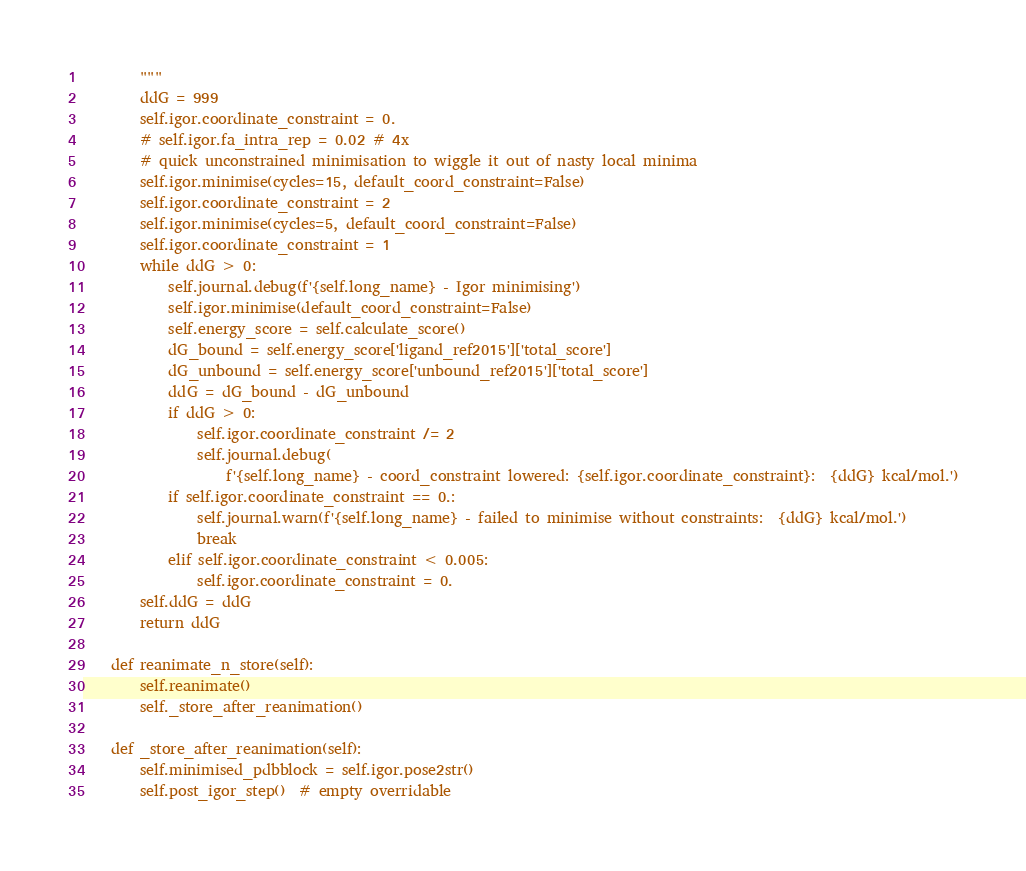<code> <loc_0><loc_0><loc_500><loc_500><_Python_>        """
        ddG = 999
        self.igor.coordinate_constraint = 0.
        # self.igor.fa_intra_rep = 0.02 # 4x
        # quick unconstrained minimisation to wiggle it out of nasty local minima
        self.igor.minimise(cycles=15, default_coord_constraint=False)
        self.igor.coordinate_constraint = 2
        self.igor.minimise(cycles=5, default_coord_constraint=False)
        self.igor.coordinate_constraint = 1
        while ddG > 0:
            self.journal.debug(f'{self.long_name} - Igor minimising')
            self.igor.minimise(default_coord_constraint=False)
            self.energy_score = self.calculate_score()
            dG_bound = self.energy_score['ligand_ref2015']['total_score']
            dG_unbound = self.energy_score['unbound_ref2015']['total_score']
            ddG = dG_bound - dG_unbound
            if ddG > 0:
                self.igor.coordinate_constraint /= 2
                self.journal.debug(
                    f'{self.long_name} - coord_constraint lowered: {self.igor.coordinate_constraint}:  {ddG} kcal/mol.')
            if self.igor.coordinate_constraint == 0.:
                self.journal.warn(f'{self.long_name} - failed to minimise without constraints:  {ddG} kcal/mol.')
                break
            elif self.igor.coordinate_constraint < 0.005:
                self.igor.coordinate_constraint = 0.
        self.ddG = ddG
        return ddG

    def reanimate_n_store(self):
        self.reanimate()
        self._store_after_reanimation()

    def _store_after_reanimation(self):
        self.minimised_pdbblock = self.igor.pose2str()
        self.post_igor_step()  # empty overridable</code> 